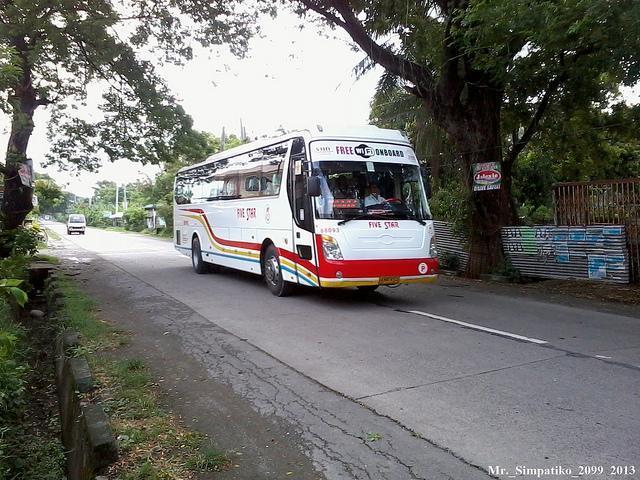How many buses are there?
Give a very brief answer. 1. 